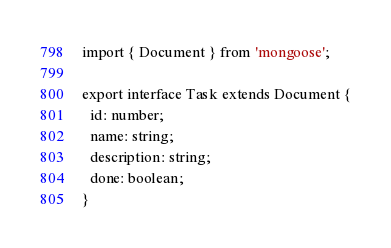Convert code to text. <code><loc_0><loc_0><loc_500><loc_500><_TypeScript_>import { Document } from 'mongoose';

export interface Task extends Document {
  id: number;
  name: string;
  description: string;
  done: boolean;
}
</code> 